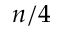Convert formula to latex. <formula><loc_0><loc_0><loc_500><loc_500>n / 4</formula> 